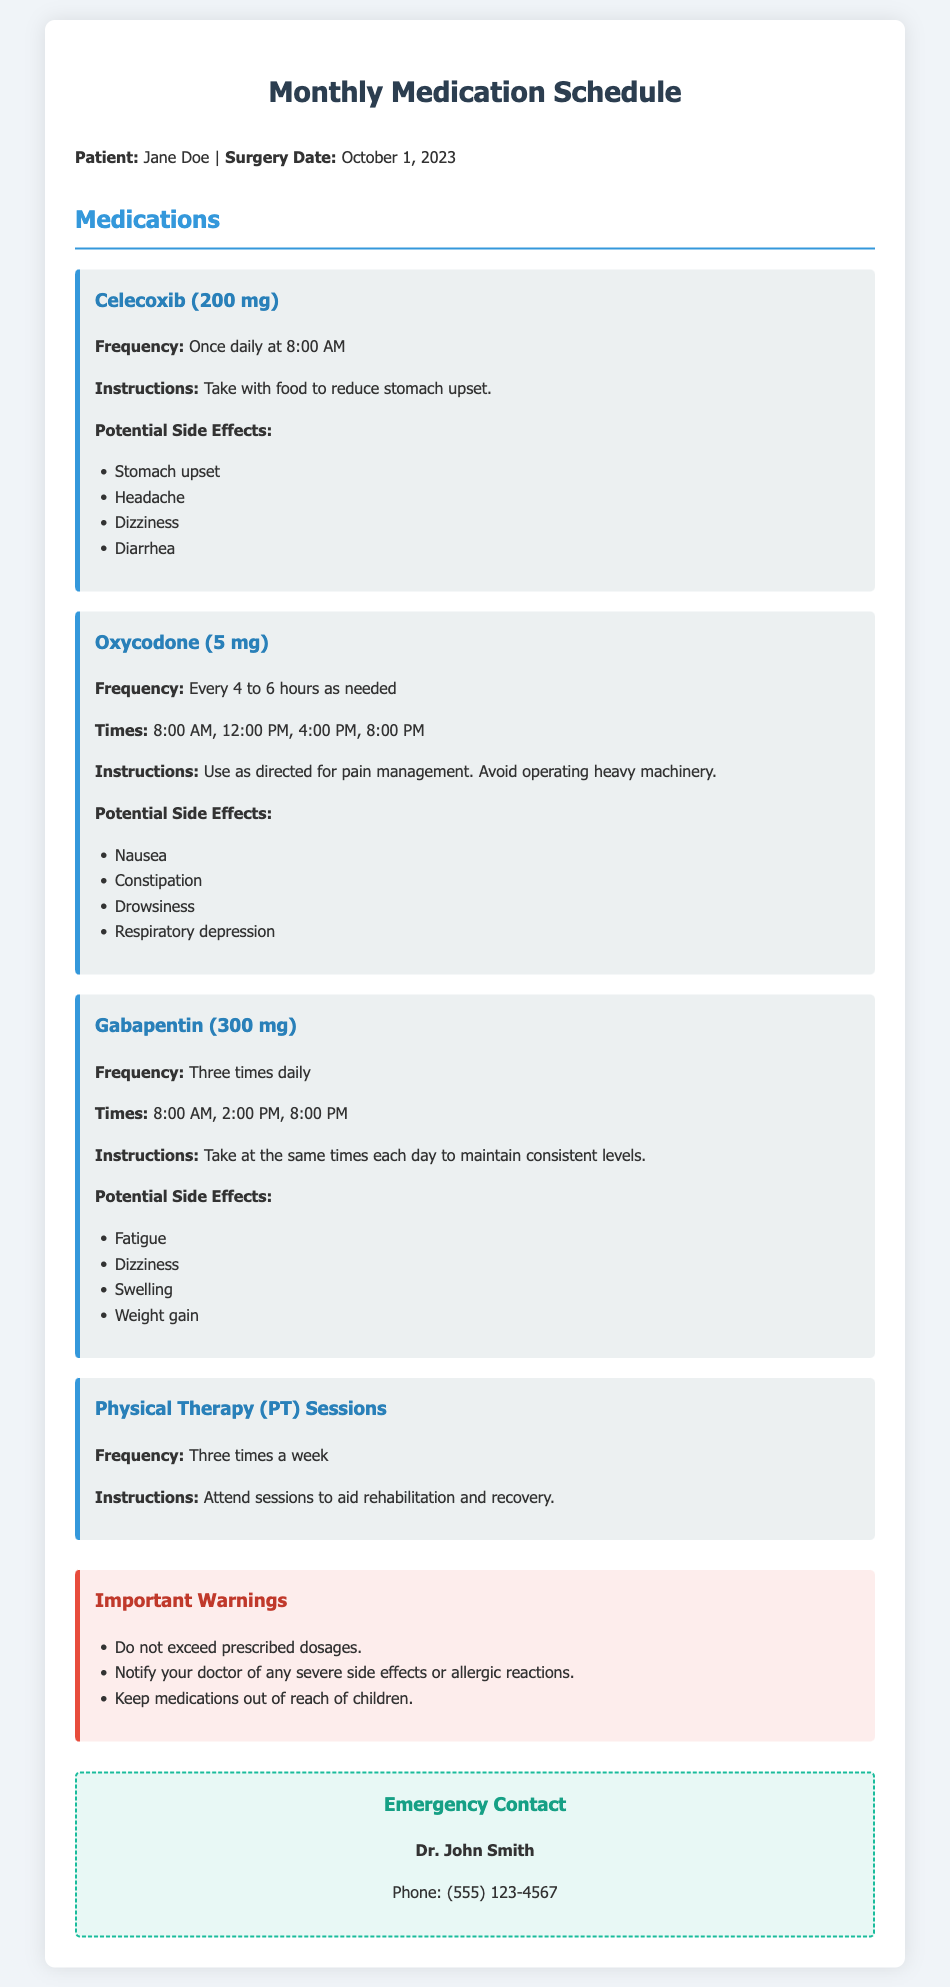What is the name of the patient? The patient is identified at the top of the document as Jane Doe.
Answer: Jane Doe What is the dosage of Celecoxib? The document specifies that Celecoxib is prescribed at a dosage of 200 mg.
Answer: 200 mg How often should Oxycodone be taken? The document states that Oxycodone should be taken every 4 to 6 hours as needed.
Answer: Every 4 to 6 hours What time should Gabapentin be taken? The document lists three specific times for taking Gabapentin: 8:00 AM, 2:00 PM, and 8:00 PM.
Answer: 8:00 AM, 2:00 PM, 8:00 PM What are two potential side effects of Oxycodone? The document outlines several side effects; two of them are nausea and constipation.
Answer: Nausea, constipation How many times a week should physical therapy sessions occur? The document mentions that physical therapy sessions occur three times a week.
Answer: Three times a week What should you do if you experience severe side effects? According to the document, you should notify your doctor of any severe side effects or allergic reactions.
Answer: Notify your doctor Who is the emergency contact listed in the document? The emergency contact person provided in the document is Dr. John Smith.
Answer: Dr. John Smith What is the warning about medication? The document warns not to exceed prescribed dosages.
Answer: Do not exceed prescribed dosages 